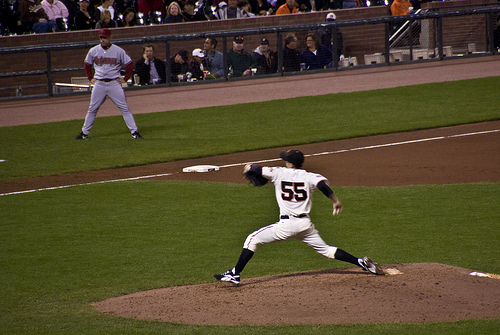Imagine the pitcher is a superhero in disguise. What powers does he have? In an alternate universe, Jake isn't just a pitcher; he's a superhero known as 'Velocity'. His superpowers include throwing pitches at lightning speed and incredible accuracy, enabling him to strike out any batter. Off the field, he uses his superhuman reflexes and strength to protect his city from evil, blending his life as a dedicated athlete and a tireless guardian. What happens next in this superhero's game and mission? As Velocity throws the final pitch of the game, the ball moves so fast that it becomes invisible to the naked eye, clinching the victory for his team and landing the final strike. However, no sooner has the game ended than his communicator buzzes. There's trouble brewing in the city. Dashing to the locker rooms, he swiftly changes into his superhero attire. Using his enhanced speed, he arrives at the heart of the city to find his arch-nemesis, The Shadow, attempting a daring heist. With a combination of his pitching precision and superhuman abilities, Velocity stops The Shadow in his tracks, ensuring that his city remains safe for another day. 